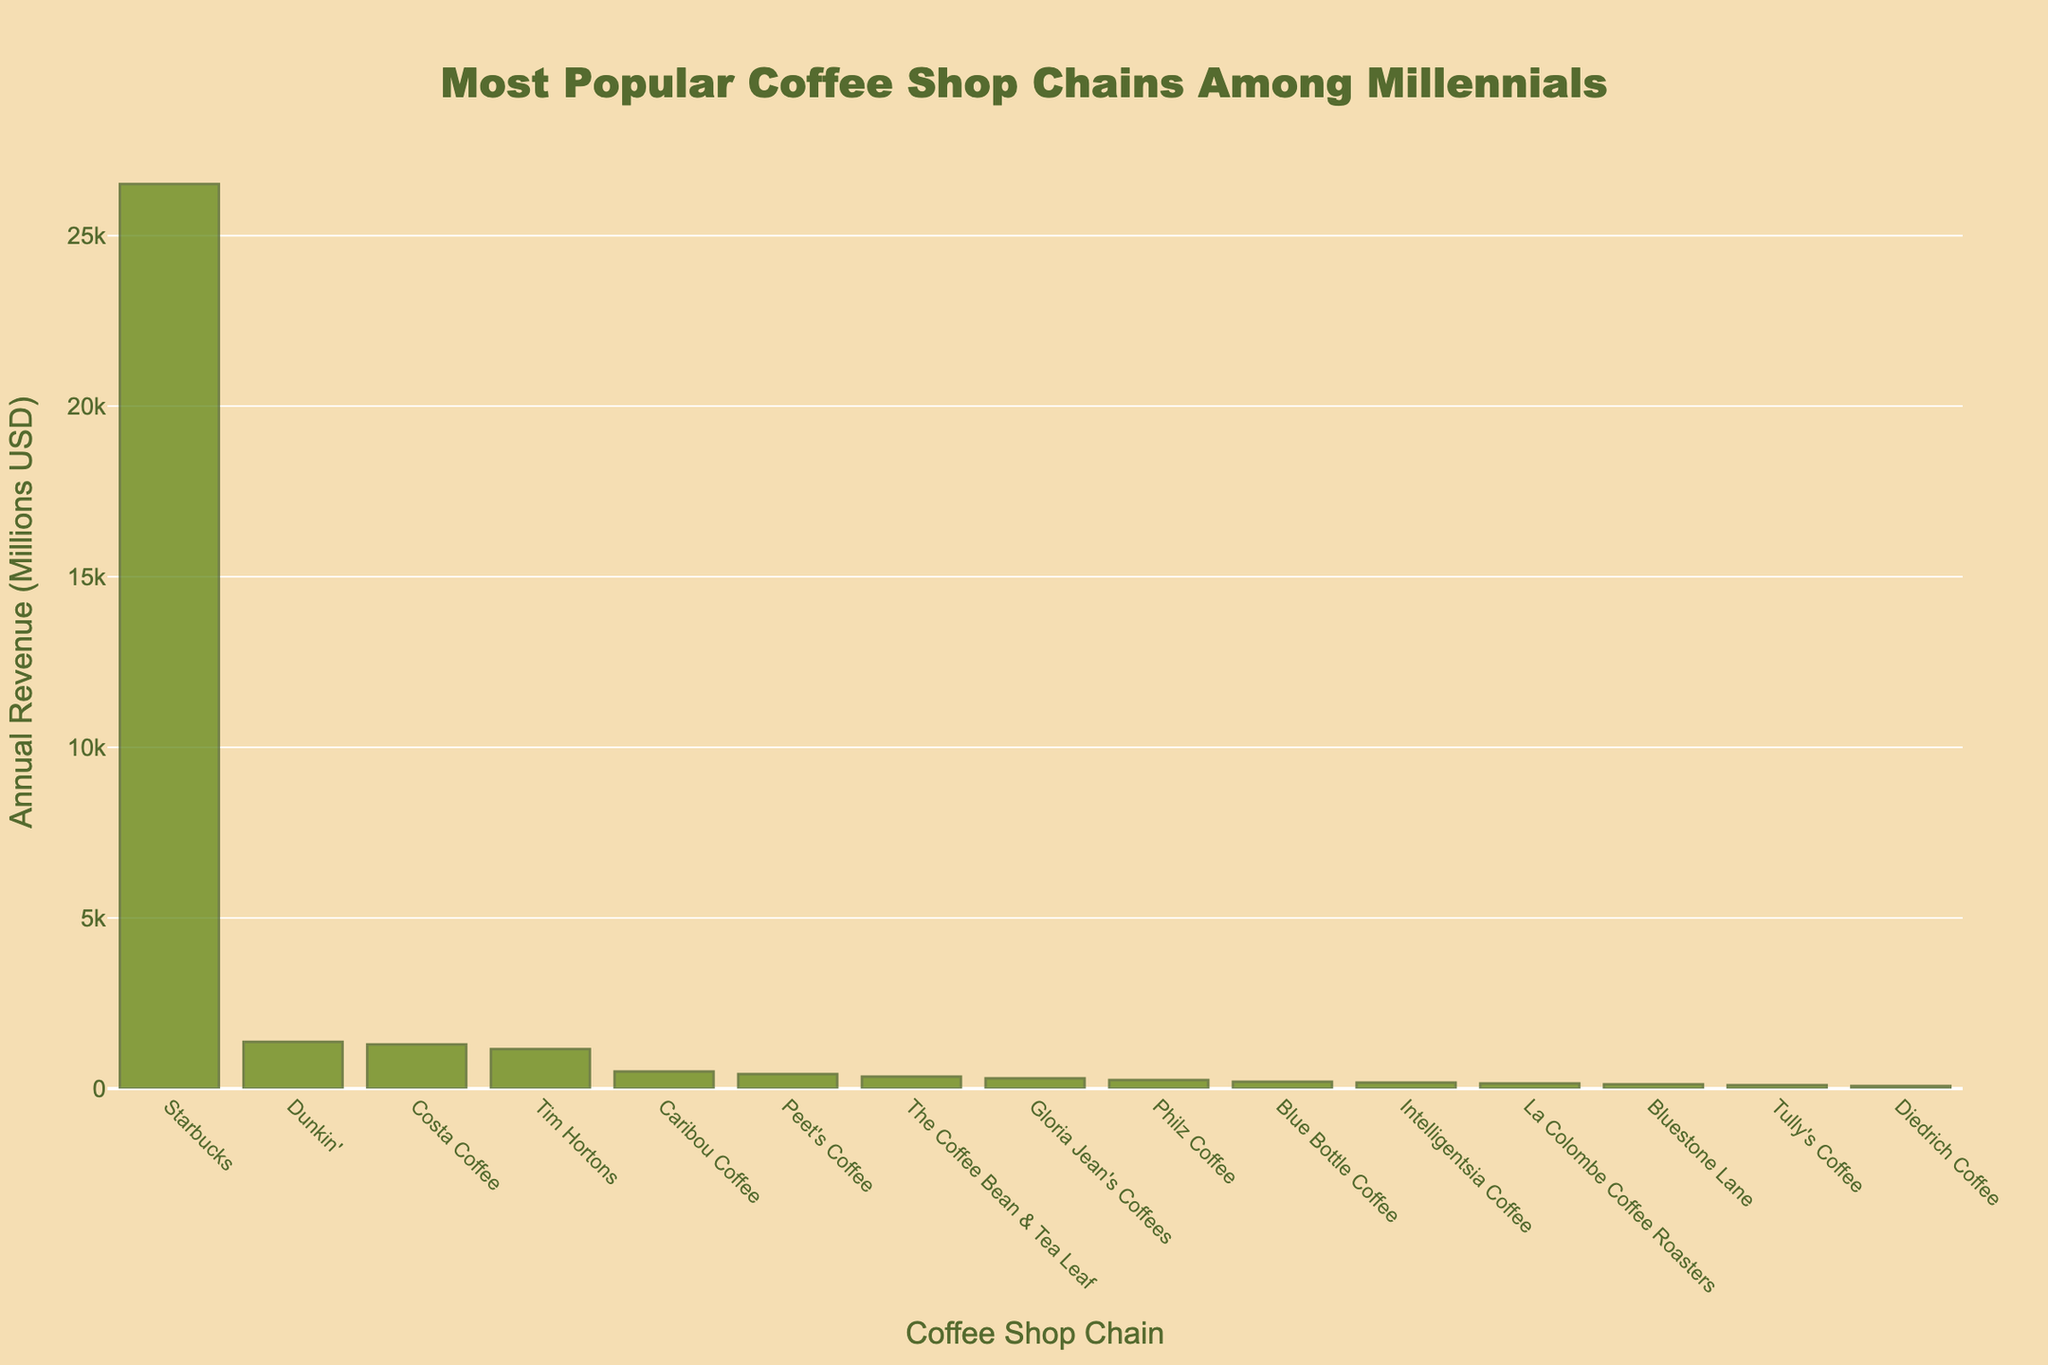what is the total annual revenue of Dunkin' and Costa Coffee combined? To find the total annual revenue of Dunkin' and Costa Coffee, sum up their individual revenues from the chart: 1370 + 1292 = 2662 million USD
Answer: 2662 which coffee shop chain has the lowest annual revenue? By observing the heights of the bars, identify the shortest bar. Tully's Coffee has the shortest bar, indicating it has the lowest revenue of 75 million USD
Answer: Tully's Coffee which coffee shop chain is more popular, Caribou Coffee or The Coffee Bean & Tea Leaf? Compare the height of the bars for Caribou Coffee and The Coffee Bean & Tea Leaf. Caribou Coffee's bar is higher, indicating a higher revenue of 500 million USD compared to The Coffee Bean & Tea Leaf's 350 million USD
Answer: Caribou Coffee how much more revenue does Starbucks generate compared to Tim Hortons? Subtract Tim Hortons' revenue from Starbucks' revenue: 26509 - 1157 = 25352 million USD
Answer: 25352 what is the average revenue of Philz Coffee, Blue Bottle Coffee, and Intelligentsia Coffee? Sum the revenues of the three coffee shops and divide by the number of shops: (250 + 200 + 175) / 3 = 625 / 3 ≈ 208.33 million USD
Answer: 208.33 which coffee shop chain is ranked 5th by annual revenue? Observe the chart and count the bars from the highest to the lowest. The 5th bar is Caribou Coffee with a revenue of 500 million USD
Answer: Caribou Coffee are there more coffee shops with revenues higher or lower than 1000 million USD? Count the number of bars with revenue values higher than 1000 million USD (4) and compare with the count of bars with revenue values lower than 1000 million USD (11)
Answer: lower which coffee shop chain might a millennial prefer if they like brands with mid-range annual revenue? A mid-range revenue bar would be around the middle of the list; Gloria Jean's Coffees, Philz Coffee, and Blue Bottle Coffee seem to fit this criteria with revenues of 300, 250, and 200 million USD
Answer: Gloria Jean's Coffees, Philz Coffee, Blue Bottle Coffee what is the difference between the highest and lowest annual revenues? Subtract the lowest annual revenue (Tully's Coffee) from the highest (Starbucks): 26509 - 75 = 26434 million USD
Answer: 26434 